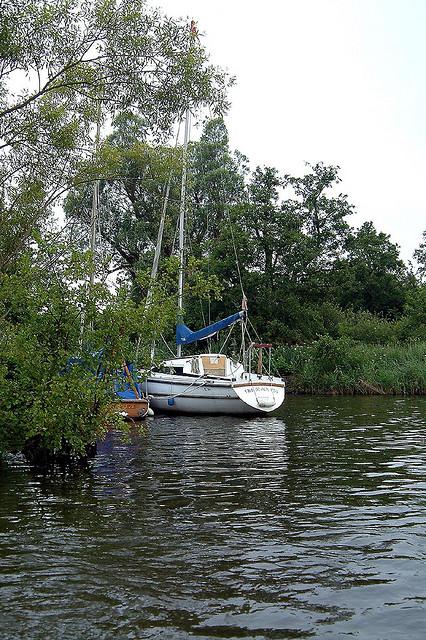What is in the front boat?
Be succinct. People. Is the water rough?
Keep it brief. No. Is the sail up or down?
Quick response, please. Down. How many people are in the water?
Concise answer only. 0. 